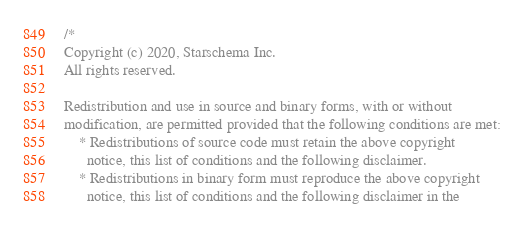<code> <loc_0><loc_0><loc_500><loc_500><_Scala_>/*
Copyright (c) 2020, Starschema Inc.
All rights reserved.

Redistribution and use in source and binary forms, with or without
modification, are permitted provided that the following conditions are met:
    * Redistributions of source code must retain the above copyright
      notice, this list of conditions and the following disclaimer.
    * Redistributions in binary form must reproduce the above copyright
      notice, this list of conditions and the following disclaimer in the</code> 